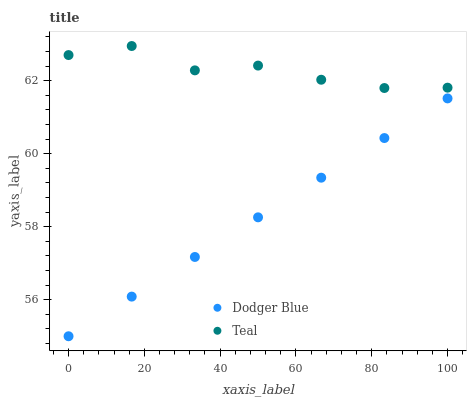Does Dodger Blue have the minimum area under the curve?
Answer yes or no. Yes. Does Teal have the maximum area under the curve?
Answer yes or no. Yes. Does Teal have the minimum area under the curve?
Answer yes or no. No. Is Dodger Blue the smoothest?
Answer yes or no. Yes. Is Teal the roughest?
Answer yes or no. Yes. Is Teal the smoothest?
Answer yes or no. No. Does Dodger Blue have the lowest value?
Answer yes or no. Yes. Does Teal have the lowest value?
Answer yes or no. No. Does Teal have the highest value?
Answer yes or no. Yes. Is Dodger Blue less than Teal?
Answer yes or no. Yes. Is Teal greater than Dodger Blue?
Answer yes or no. Yes. Does Dodger Blue intersect Teal?
Answer yes or no. No. 